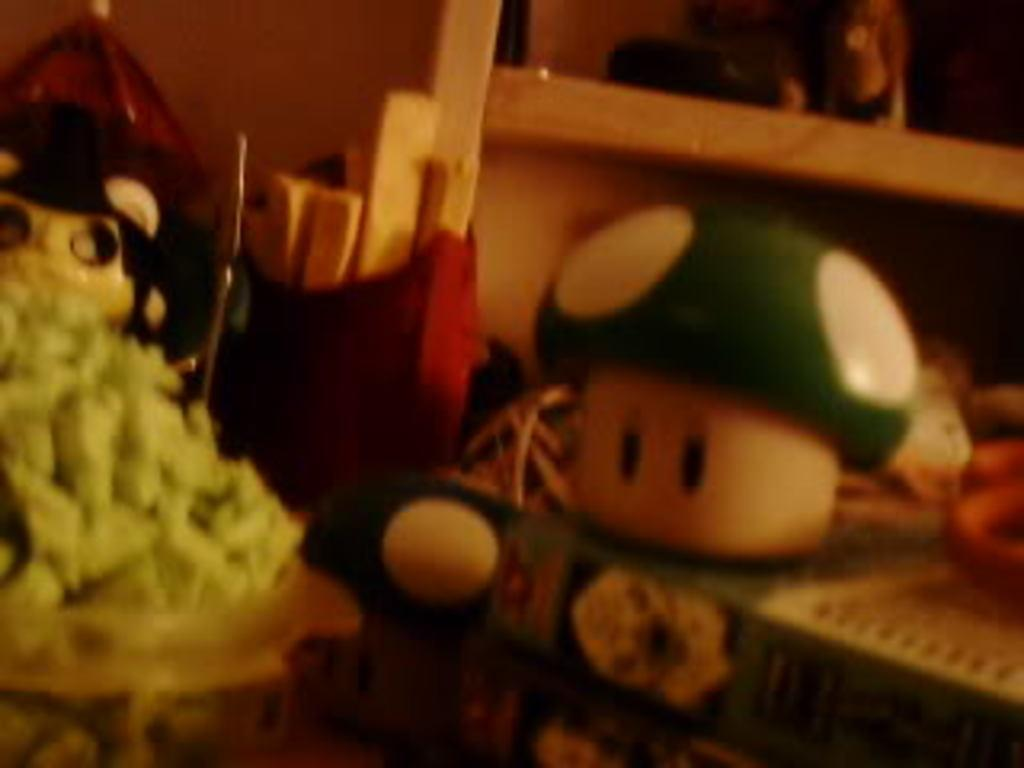What type of objects can be seen in the image? There are toys and wooden objects in the image. Can you describe the setting of the image? There is a wall in the image, which suggests an indoor setting. What type of pest can be seen crawling on the toys in the image? There is no pest visible in the image; it only features toys and wooden objects. 